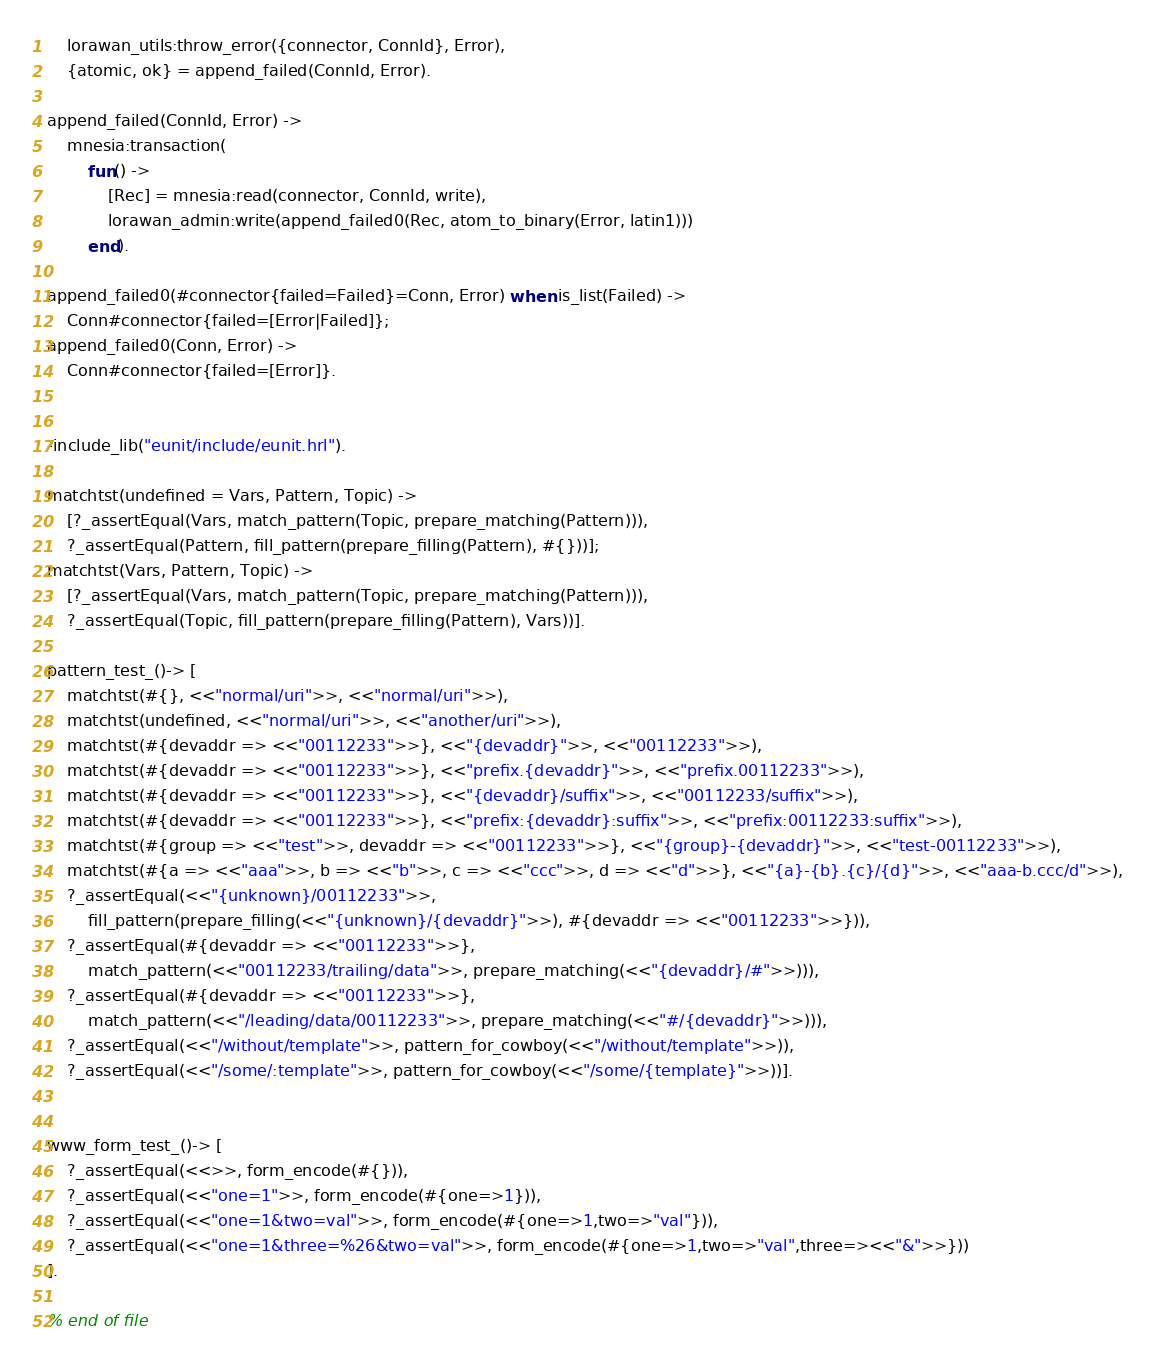Convert code to text. <code><loc_0><loc_0><loc_500><loc_500><_Erlang_>    lorawan_utils:throw_error({connector, ConnId}, Error),
    {atomic, ok} = append_failed(ConnId, Error).

append_failed(ConnId, Error) ->
    mnesia:transaction(
        fun() ->
            [Rec] = mnesia:read(connector, ConnId, write),
            lorawan_admin:write(append_failed0(Rec, atom_to_binary(Error, latin1)))
        end).

append_failed0(#connector{failed=Failed}=Conn, Error) when is_list(Failed) ->
    Conn#connector{failed=[Error|Failed]};
append_failed0(Conn, Error) ->
    Conn#connector{failed=[Error]}.


-include_lib("eunit/include/eunit.hrl").

matchtst(undefined = Vars, Pattern, Topic) ->
    [?_assertEqual(Vars, match_pattern(Topic, prepare_matching(Pattern))),
    ?_assertEqual(Pattern, fill_pattern(prepare_filling(Pattern), #{}))];
matchtst(Vars, Pattern, Topic) ->
    [?_assertEqual(Vars, match_pattern(Topic, prepare_matching(Pattern))),
    ?_assertEqual(Topic, fill_pattern(prepare_filling(Pattern), Vars))].

pattern_test_()-> [
    matchtst(#{}, <<"normal/uri">>, <<"normal/uri">>),
    matchtst(undefined, <<"normal/uri">>, <<"another/uri">>),
    matchtst(#{devaddr => <<"00112233">>}, <<"{devaddr}">>, <<"00112233">>),
    matchtst(#{devaddr => <<"00112233">>}, <<"prefix.{devaddr}">>, <<"prefix.00112233">>),
    matchtst(#{devaddr => <<"00112233">>}, <<"{devaddr}/suffix">>, <<"00112233/suffix">>),
    matchtst(#{devaddr => <<"00112233">>}, <<"prefix:{devaddr}:suffix">>, <<"prefix:00112233:suffix">>),
    matchtst(#{group => <<"test">>, devaddr => <<"00112233">>}, <<"{group}-{devaddr}">>, <<"test-00112233">>),
    matchtst(#{a => <<"aaa">>, b => <<"b">>, c => <<"ccc">>, d => <<"d">>}, <<"{a}-{b}.{c}/{d}">>, <<"aaa-b.ccc/d">>),
    ?_assertEqual(<<"{unknown}/00112233">>,
        fill_pattern(prepare_filling(<<"{unknown}/{devaddr}">>), #{devaddr => <<"00112233">>})),
    ?_assertEqual(#{devaddr => <<"00112233">>},
        match_pattern(<<"00112233/trailing/data">>, prepare_matching(<<"{devaddr}/#">>))),
    ?_assertEqual(#{devaddr => <<"00112233">>},
        match_pattern(<<"/leading/data/00112233">>, prepare_matching(<<"#/{devaddr}">>))),
    ?_assertEqual(<<"/without/template">>, pattern_for_cowboy(<<"/without/template">>)),
    ?_assertEqual(<<"/some/:template">>, pattern_for_cowboy(<<"/some/{template}">>))].


www_form_test_()-> [
    ?_assertEqual(<<>>, form_encode(#{})),
    ?_assertEqual(<<"one=1">>, form_encode(#{one=>1})),
    ?_assertEqual(<<"one=1&two=val">>, form_encode(#{one=>1,two=>"val"})),
    ?_assertEqual(<<"one=1&three=%26&two=val">>, form_encode(#{one=>1,two=>"val",three=><<"&">>}))
].

% end of file
</code> 